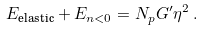<formula> <loc_0><loc_0><loc_500><loc_500>E _ { \text {elastic} } + E _ { n < 0 } = N _ { p } G ^ { \prime } \eta ^ { 2 } \, .</formula> 